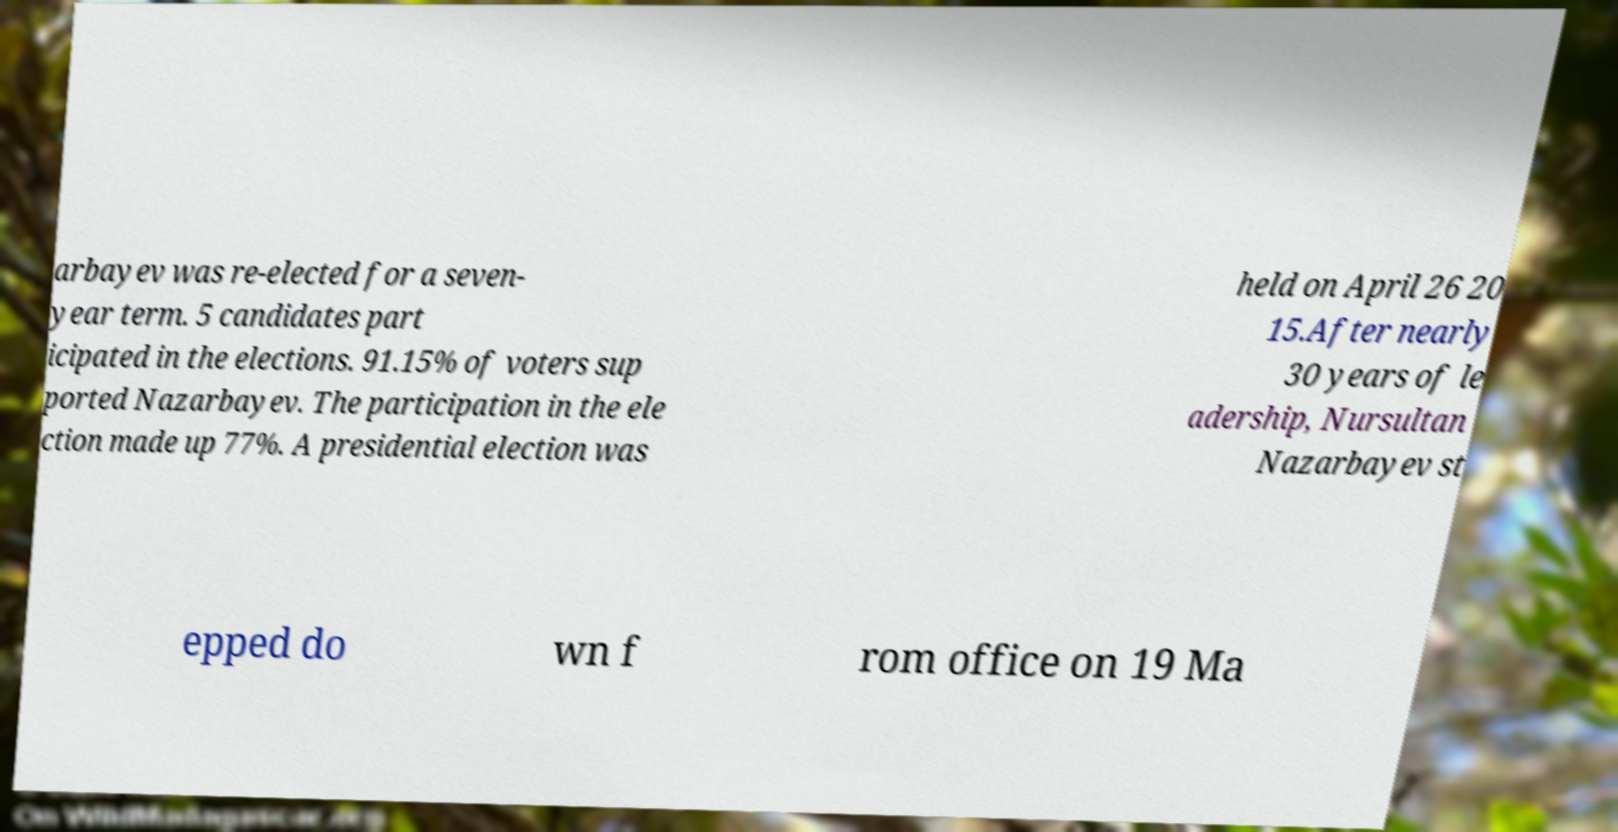There's text embedded in this image that I need extracted. Can you transcribe it verbatim? arbayev was re-elected for a seven- year term. 5 candidates part icipated in the elections. 91.15% of voters sup ported Nazarbayev. The participation in the ele ction made up 77%. A presidential election was held on April 26 20 15.After nearly 30 years of le adership, Nursultan Nazarbayev st epped do wn f rom office on 19 Ma 